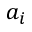Convert formula to latex. <formula><loc_0><loc_0><loc_500><loc_500>a _ { i }</formula> 